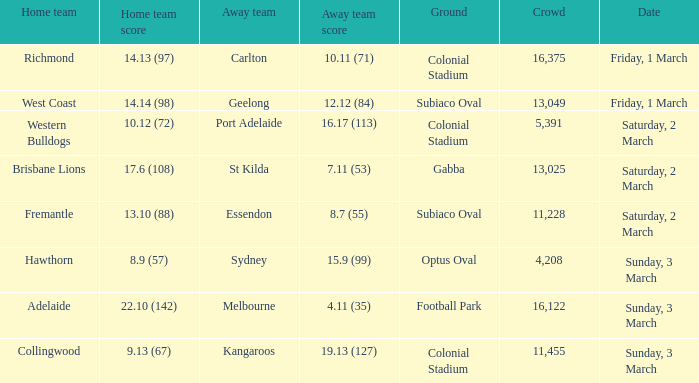Where did the away team essendon have their home base? Subiaco Oval. 